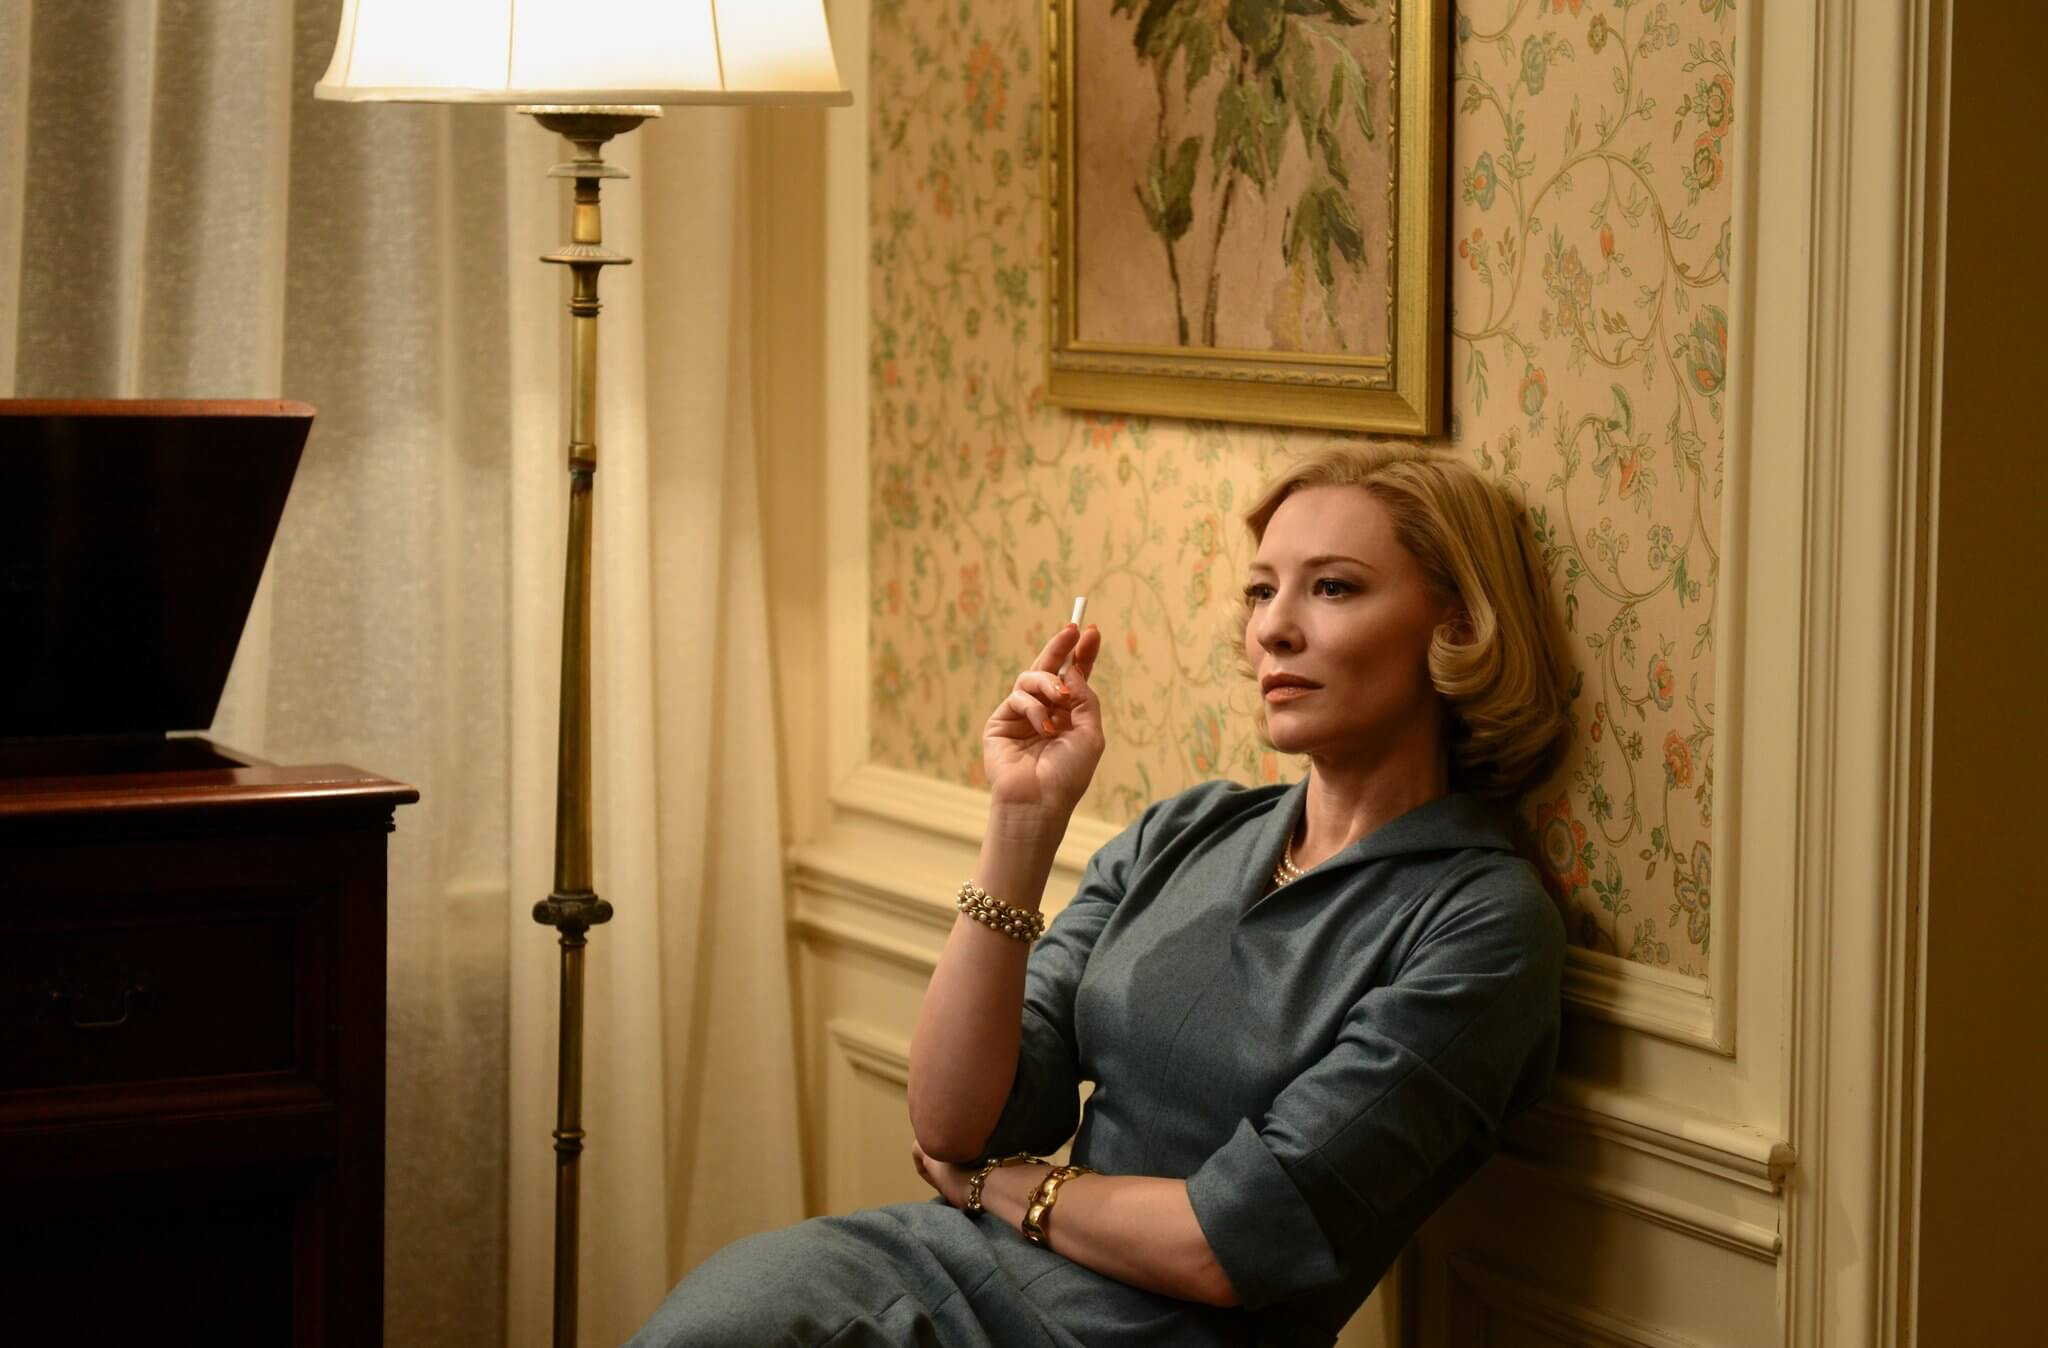Can you elaborate on the elements of the picture provided? In this evocative scene, the character, depicted sitting in a tastefully decorated room, exudes a serene yet somewhat melancholic demeanor. She is dressed in a refined blue outfit accessorized with golden bracelets, which complements the floral wallpaper background. Her seated posture on a beige armchair and the subtle handling of a cigarette add layers to her contemplative mood. The lamp and the wooden desk in the background enrich the setting, giving clues about her personal or professional life that might intersect with the story line. The soft lighting and muted colors create an ambiance that suggests introspection or a pivotal moment in her narrative. 